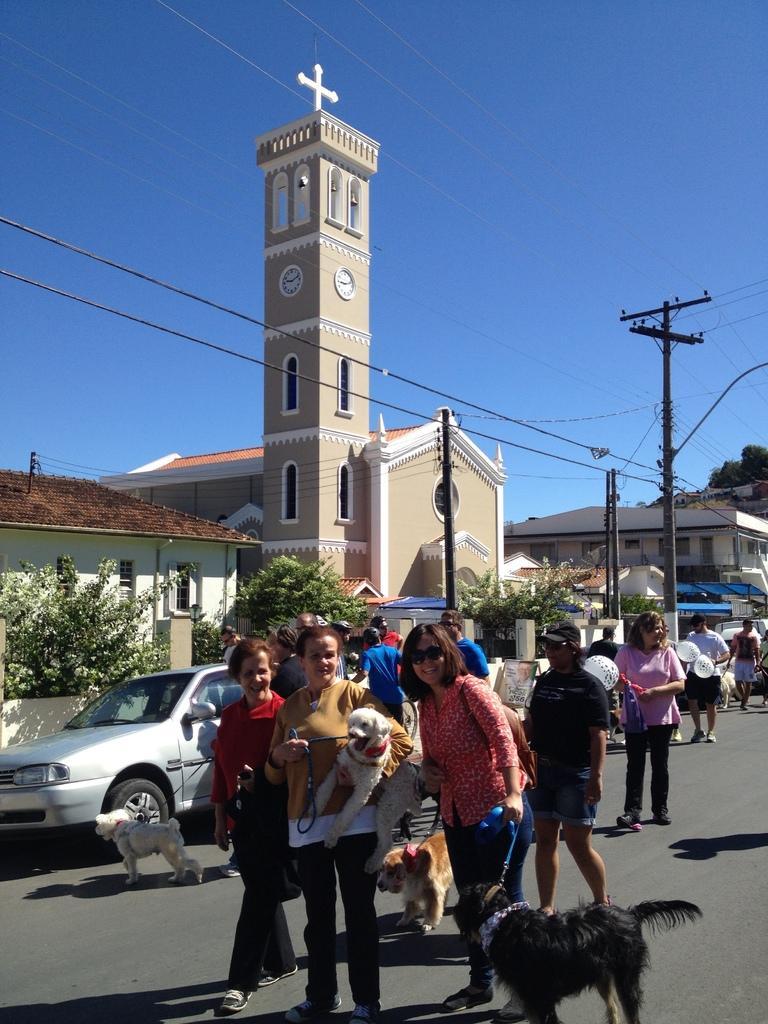Could you give a brief overview of what you see in this image? As we can see in the image, there is a building, sky, current pole, houses, trees and few people standing on road. On road there are dogs and a car. 